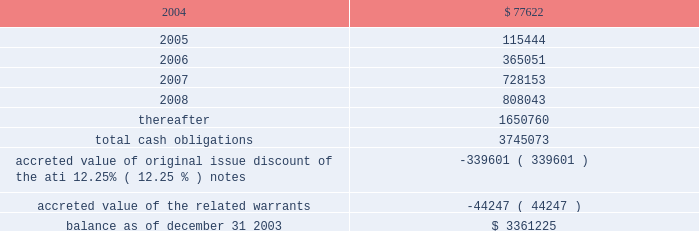American tower corporation and subsidiaries notes to consolidated financial statements 2014 ( continued ) maturities 2014as of december 31 , 2003 , aggregate principal payments of long-term debt , including capital leases , for the next five years and thereafter are estimated to be ( in thousands ) : year ending december 31 .
The holders of the company 2019s convertible notes have the right to require the company to repurchase their notes on specified dates prior to their maturity dates in 2009 and 2010 , but the company may pay the purchase price by issuing shares of class a common stock , subject to certain conditions .
Obligations with respect to the right of the holders to put the 6.25% ( 6.25 % ) notes and 5.0% ( 5.0 % ) notes have been included in the table above as if such notes mature on the date of their put rights in 2006 and 2007 , respectively .
( see note 19. ) 8 .
Derivative financial instruments under the terms of the credit facilities , the company is required to enter into interest rate protection agreements on at least 50% ( 50 % ) of its variable rate debt .
Under these agreements , the company is exposed to credit risk to the extent that a counterparty fails to meet the terms of a contract .
Such exposure is limited to the current value of the contract at the time the counterparty fails to perform .
The company believes its contracts as of december 31 , 2003 are with credit worthy institutions .
As of december 31 , 2003 , the company had three interest rate caps outstanding that include an aggregate notional amount of $ 500.0 million ( each at an interest rate of 5% ( 5 % ) ) and expire in 2004 .
As of december 31 , 2003 and 2002 , liabilities related to derivative financial instruments of $ 0.0 million and $ 15.5 million are reflected in other long-term liabilities in the accompanying consolidated balance sheet .
During the year ended december 31 , 2003 , the company recorded an unrealized loss of approximately $ 0.3 million ( net of a tax benefit of approximately $ 0.2 million ) in other comprehensive loss for the change in fair value of cash flow hedges and reclassified $ 5.9 million ( net of a tax benefit of approximately $ 3.2 million ) into results of operations .
During the year ended december 31 , 2002 , the company recorded an unrealized loss of approximately $ 9.1 million ( net of a tax benefit of approximately $ 4.9 million ) in other comprehensive loss for the change in fair value of cash flow hedges and reclassified $ 19.5 million ( net of a tax benefit of approximately $ 10.5 million ) into results of operations .
Hedge ineffectiveness resulted in a gain of approximately $ 1.0 million and a loss of approximately $ 2.2 million for the years ended december 31 , 2002 and 2001 , respectively , which are recorded in loss on investments and other expense in the accompanying consolidated statements of operations for those periods .
The company records the changes in fair value of its derivative instruments that are not accounted for as hedges in loss on investments and other expense .
The company does not anticipate reclassifying any derivative losses into its statement of operations within the next twelve months , as there are no amounts included in other comprehensive loss as of december 31 , 2003. .
What will be the balance of aggregate principal payments of long-term debt as of december 31 , 2004 , assuming that no new debt is issued? 
Computations: (3361225 - 77622)
Answer: 3283603.0. 